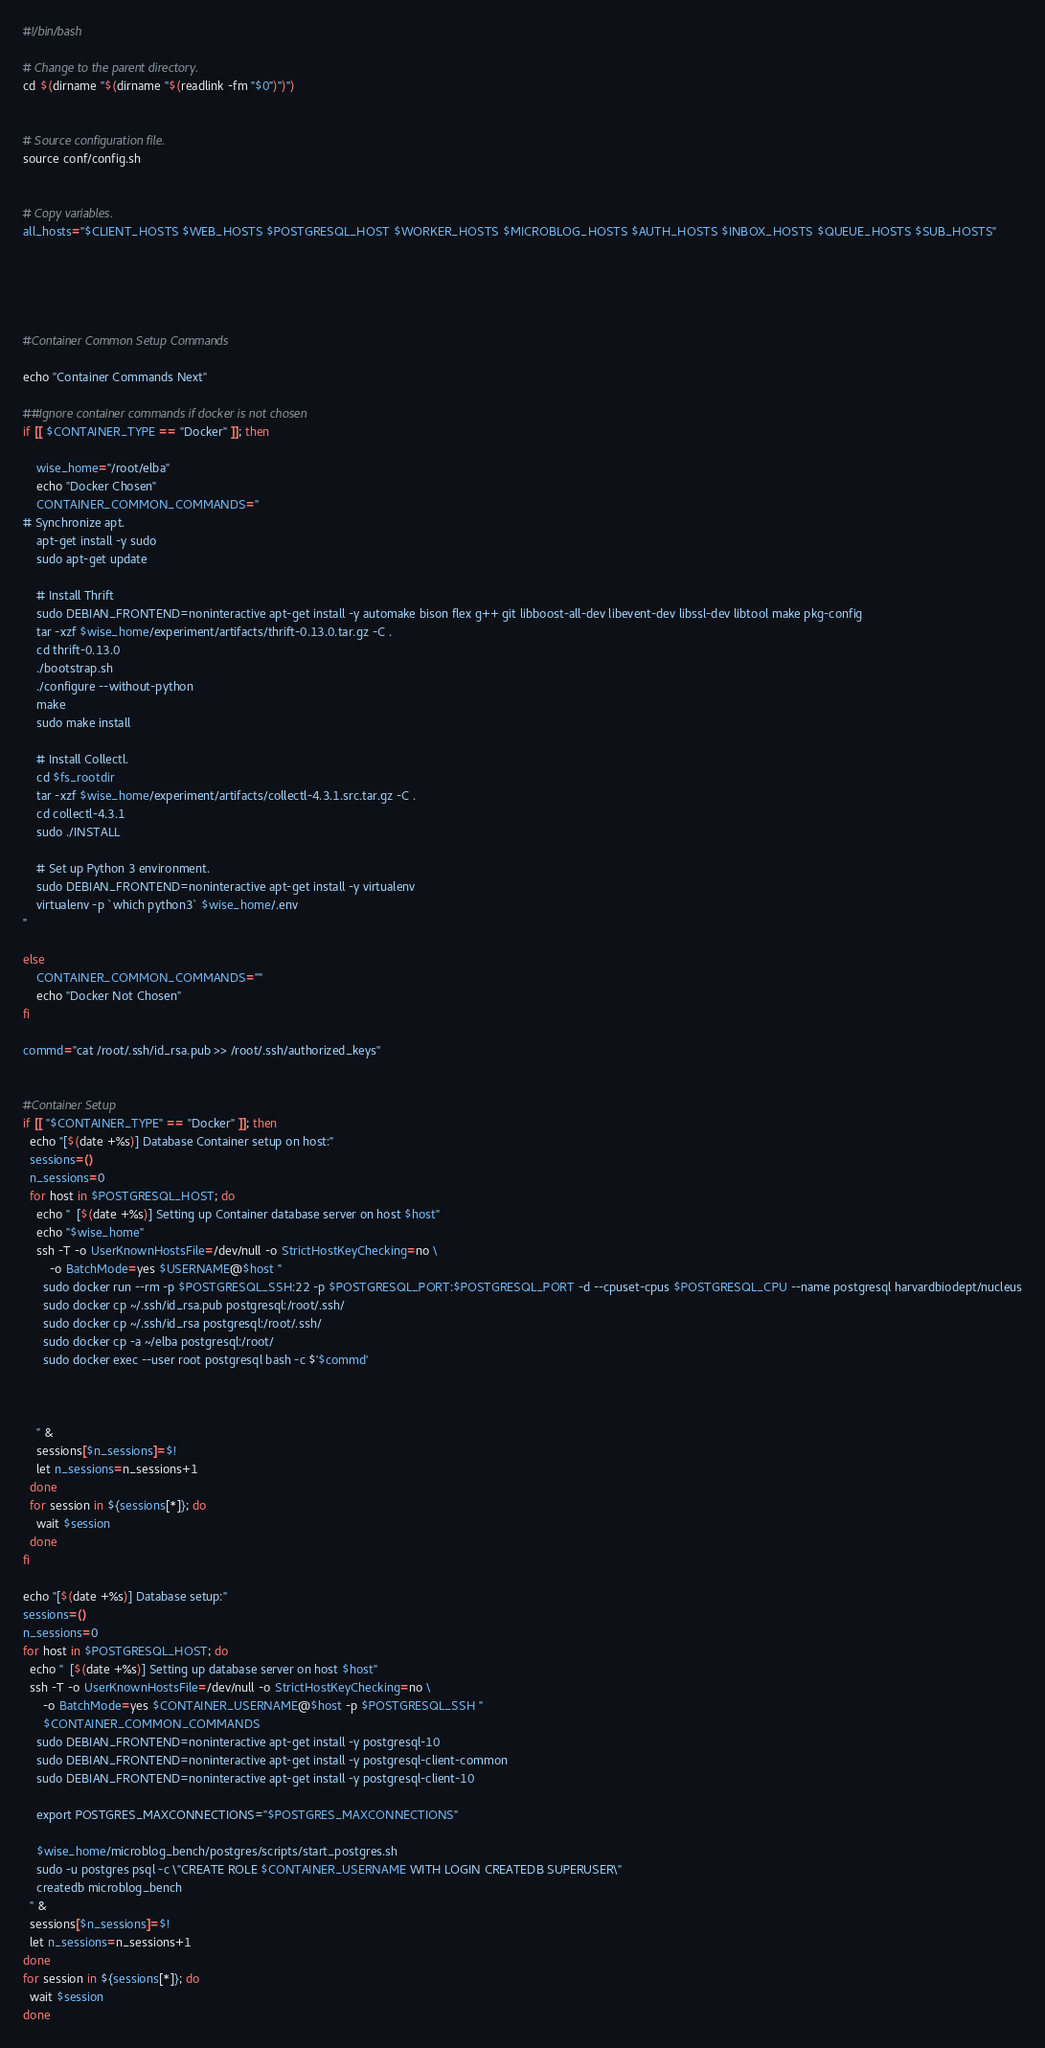Convert code to text. <code><loc_0><loc_0><loc_500><loc_500><_Bash_>#!/bin/bash

# Change to the parent directory.
cd $(dirname "$(dirname "$(readlink -fm "$0")")")


# Source configuration file.
source conf/config.sh


# Copy variables.
all_hosts="$CLIENT_HOSTS $WEB_HOSTS $POSTGRESQL_HOST $WORKER_HOSTS $MICROBLOG_HOSTS $AUTH_HOSTS $INBOX_HOSTS $QUEUE_HOSTS $SUB_HOSTS"





#Container Common Setup Commands

echo "Container Commands Next"

##Ignore container commands if docker is not chosen
if [[ $CONTAINER_TYPE == "Docker" ]]; then
    
    wise_home="/root/elba"
    echo "Docker Chosen"
    CONTAINER_COMMON_COMMANDS="
# Synchronize apt.
    apt-get install -y sudo
    sudo apt-get update
  
    # Install Thrift
    sudo DEBIAN_FRONTEND=noninteractive apt-get install -y automake bison flex g++ git libboost-all-dev libevent-dev libssl-dev libtool make pkg-config
    tar -xzf $wise_home/experiment/artifacts/thrift-0.13.0.tar.gz -C .
    cd thrift-0.13.0
    ./bootstrap.sh
    ./configure --without-python
    make
    sudo make install

    # Install Collectl.
    cd $fs_rootdir
    tar -xzf $wise_home/experiment/artifacts/collectl-4.3.1.src.tar.gz -C .
    cd collectl-4.3.1
    sudo ./INSTALL

    # Set up Python 3 environment.
    sudo DEBIAN_FRONTEND=noninteractive apt-get install -y virtualenv
    virtualenv -p `which python3` $wise_home/.env
"

else
    CONTAINER_COMMON_COMMANDS=""
    echo "Docker Not Chosen"
fi

commd="cat /root/.ssh/id_rsa.pub >> /root/.ssh/authorized_keys"


#Container Setup
if [[ "$CONTAINER_TYPE" == "Docker" ]]; then
  echo "[$(date +%s)] Database Container setup on host:"
  sessions=()
  n_sessions=0
  for host in $POSTGRESQL_HOST; do
    echo "  [$(date +%s)] Setting up Container database server on host $host"
    echo "$wise_home"
    ssh -T -o UserKnownHostsFile=/dev/null -o StrictHostKeyChecking=no \
        -o BatchMode=yes $USERNAME@$host "
      sudo docker run --rm -p $POSTGRESQL_SSH:22 -p $POSTGRESQL_PORT:$POSTGRESQL_PORT -d --cpuset-cpus $POSTGRESQL_CPU --name postgresql harvardbiodept/nucleus
      sudo docker cp ~/.ssh/id_rsa.pub postgresql:/root/.ssh/
      sudo docker cp ~/.ssh/id_rsa postgresql:/root/.ssh/
      sudo docker cp -a ~/elba postgresql:/root/
      sudo docker exec --user root postgresql bash -c $'$commd'
      
      

    " &
    sessions[$n_sessions]=$!
    let n_sessions=n_sessions+1
  done
  for session in ${sessions[*]}; do
    wait $session
  done
fi

echo "[$(date +%s)] Database setup:"
sessions=()
n_sessions=0
for host in $POSTGRESQL_HOST; do
  echo "  [$(date +%s)] Setting up database server on host $host"
  ssh -T -o UserKnownHostsFile=/dev/null -o StrictHostKeyChecking=no \
      -o BatchMode=yes $CONTAINER_USERNAME@$host -p $POSTGRESQL_SSH "
      $CONTAINER_COMMON_COMMANDS
    sudo DEBIAN_FRONTEND=noninteractive apt-get install -y postgresql-10
    sudo DEBIAN_FRONTEND=noninteractive apt-get install -y postgresql-client-common
    sudo DEBIAN_FRONTEND=noninteractive apt-get install -y postgresql-client-10

    export POSTGRES_MAXCONNECTIONS="$POSTGRES_MAXCONNECTIONS"

    $wise_home/microblog_bench/postgres/scripts/start_postgres.sh
    sudo -u postgres psql -c \"CREATE ROLE $CONTAINER_USERNAME WITH LOGIN CREATEDB SUPERUSER\"
    createdb microblog_bench
  " &
  sessions[$n_sessions]=$!
  let n_sessions=n_sessions+1
done
for session in ${sessions[*]}; do
  wait $session
done</code> 